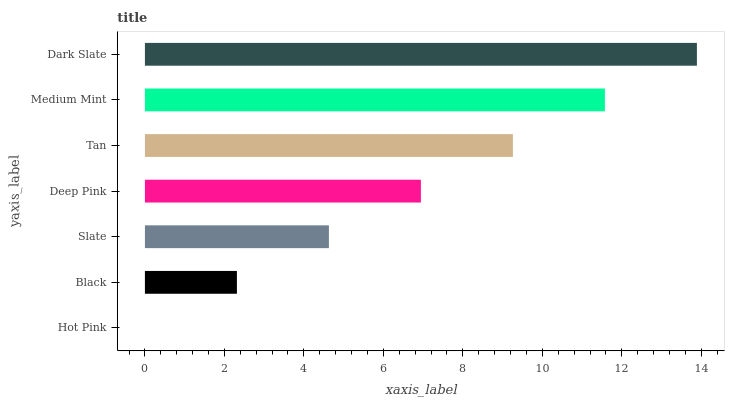Is Hot Pink the minimum?
Answer yes or no. Yes. Is Dark Slate the maximum?
Answer yes or no. Yes. Is Black the minimum?
Answer yes or no. No. Is Black the maximum?
Answer yes or no. No. Is Black greater than Hot Pink?
Answer yes or no. Yes. Is Hot Pink less than Black?
Answer yes or no. Yes. Is Hot Pink greater than Black?
Answer yes or no. No. Is Black less than Hot Pink?
Answer yes or no. No. Is Deep Pink the high median?
Answer yes or no. Yes. Is Deep Pink the low median?
Answer yes or no. Yes. Is Dark Slate the high median?
Answer yes or no. No. Is Dark Slate the low median?
Answer yes or no. No. 